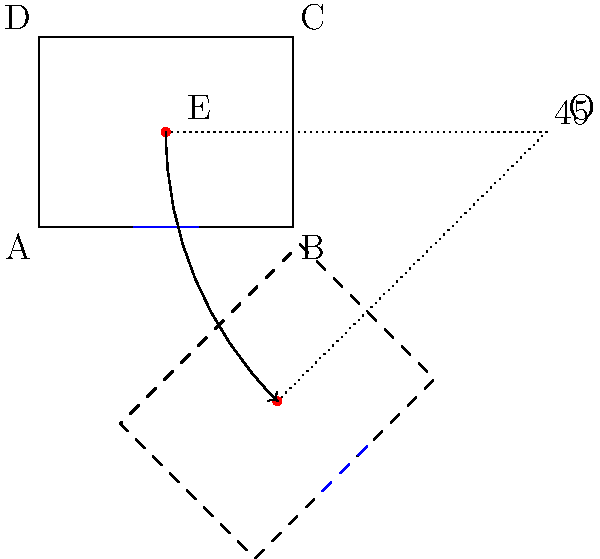After an earthquake, a building inspector needs to rotate a blueprint 45° clockwise around point O (8, 1.5) to assess structural integrity. If point E on the original blueprint is at (2, 1.5), what are the coordinates of E after rotation? Round your answer to two decimal places. To find the coordinates of point E after rotation, we can follow these steps:

1) First, we need to translate the point E relative to the center of rotation O:
   $E_{relative} = (2 - 8, 1.5 - 1.5) = (-6, 0)$

2) Now, we can use the rotation matrix for a 45° clockwise rotation:
   $R = \begin{bmatrix} \cos(-45°) & -\sin(-45°) \\ \sin(-45°) & \cos(-45°) \end{bmatrix} = \begin{bmatrix} \frac{\sqrt{2}}{2} & \frac{\sqrt{2}}{2} \\ -\frac{\sqrt{2}}{2} & \frac{\sqrt{2}}{2} \end{bmatrix}$

3) Multiply the rotation matrix by the relative coordinates:
   $E_{rotated\_relative} = R \cdot E_{relative} = \begin{bmatrix} \frac{\sqrt{2}}{2} & \frac{\sqrt{2}}{2} \\ -\frac{\sqrt{2}}{2} & \frac{\sqrt{2}}{2} \end{bmatrix} \cdot \begin{bmatrix} -6 \\ 0 \end{bmatrix} = \begin{bmatrix} -3\sqrt{2} \\ 3\sqrt{2} \end{bmatrix}$

4) Translate back to the original coordinate system by adding the coordinates of O:
   $E_{final} = (-3\sqrt{2} + 8, 3\sqrt{2} + 1.5)$

5) Simplify and round to two decimal places:
   $E_{final} \approx (3.76, 5.74)$
Answer: (3.76, 5.74) 